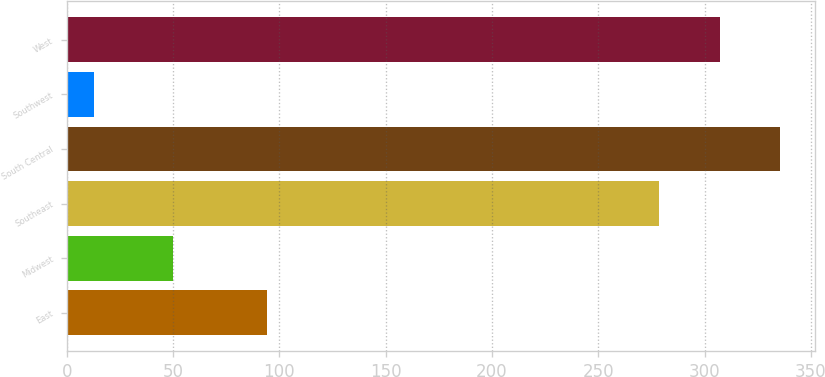Convert chart to OTSL. <chart><loc_0><loc_0><loc_500><loc_500><bar_chart><fcel>East<fcel>Midwest<fcel>Southeast<fcel>South Central<fcel>Southwest<fcel>West<nl><fcel>94.2<fcel>49.8<fcel>278.7<fcel>335.4<fcel>13.1<fcel>307.05<nl></chart> 